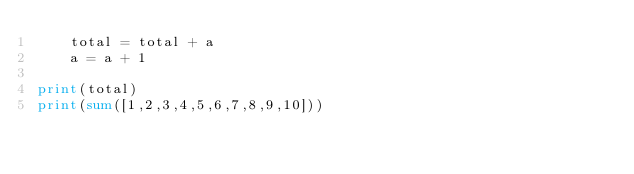Convert code to text. <code><loc_0><loc_0><loc_500><loc_500><_Python_>    total = total + a
    a = a + 1

print(total)
print(sum([1,2,3,4,5,6,7,8,9,10]))
</code> 